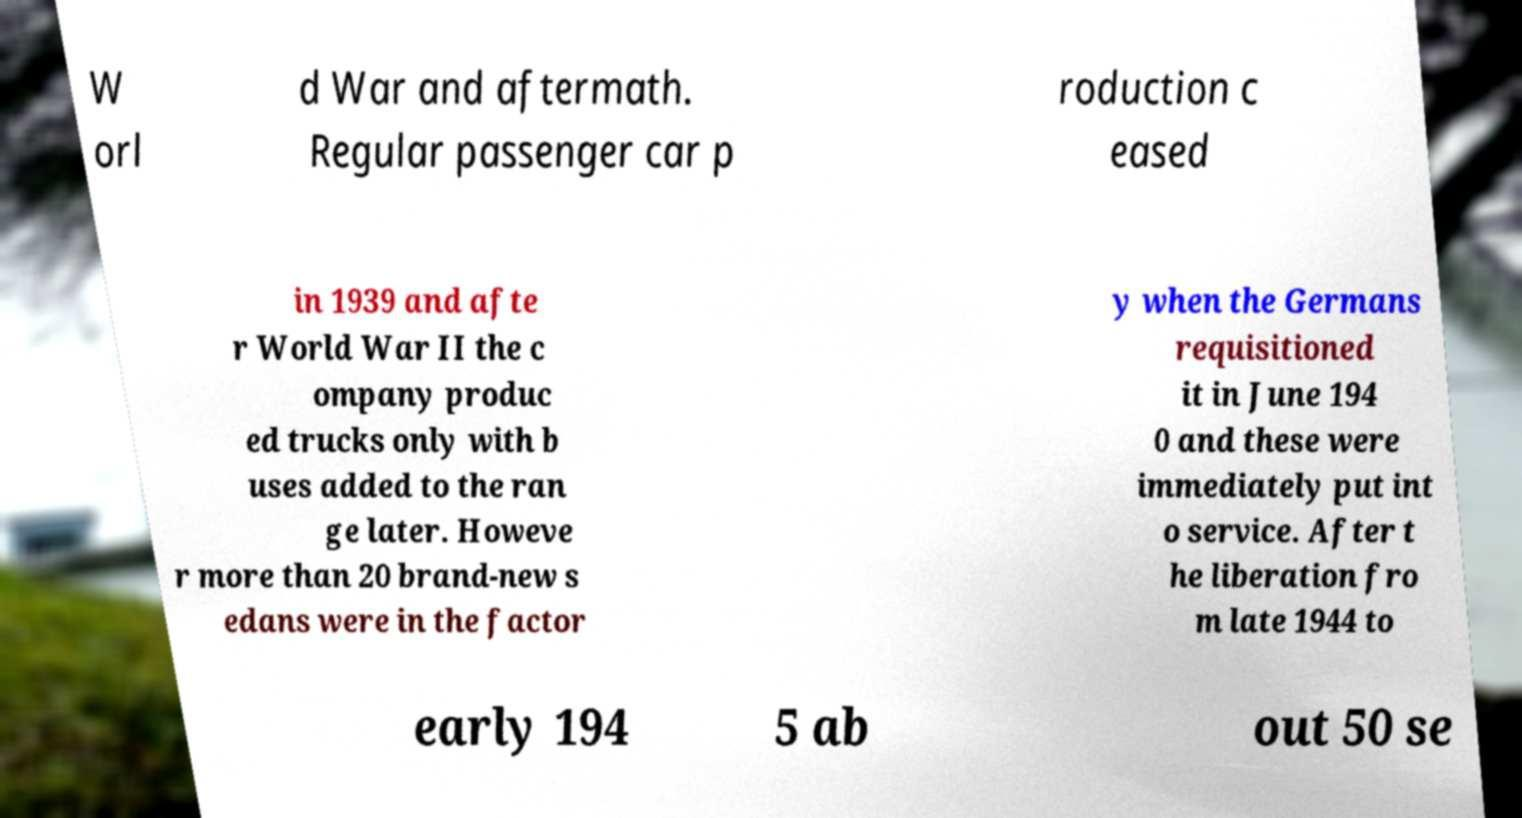Please read and relay the text visible in this image. What does it say? W orl d War and aftermath. Regular passenger car p roduction c eased in 1939 and afte r World War II the c ompany produc ed trucks only with b uses added to the ran ge later. Howeve r more than 20 brand-new s edans were in the factor y when the Germans requisitioned it in June 194 0 and these were immediately put int o service. After t he liberation fro m late 1944 to early 194 5 ab out 50 se 